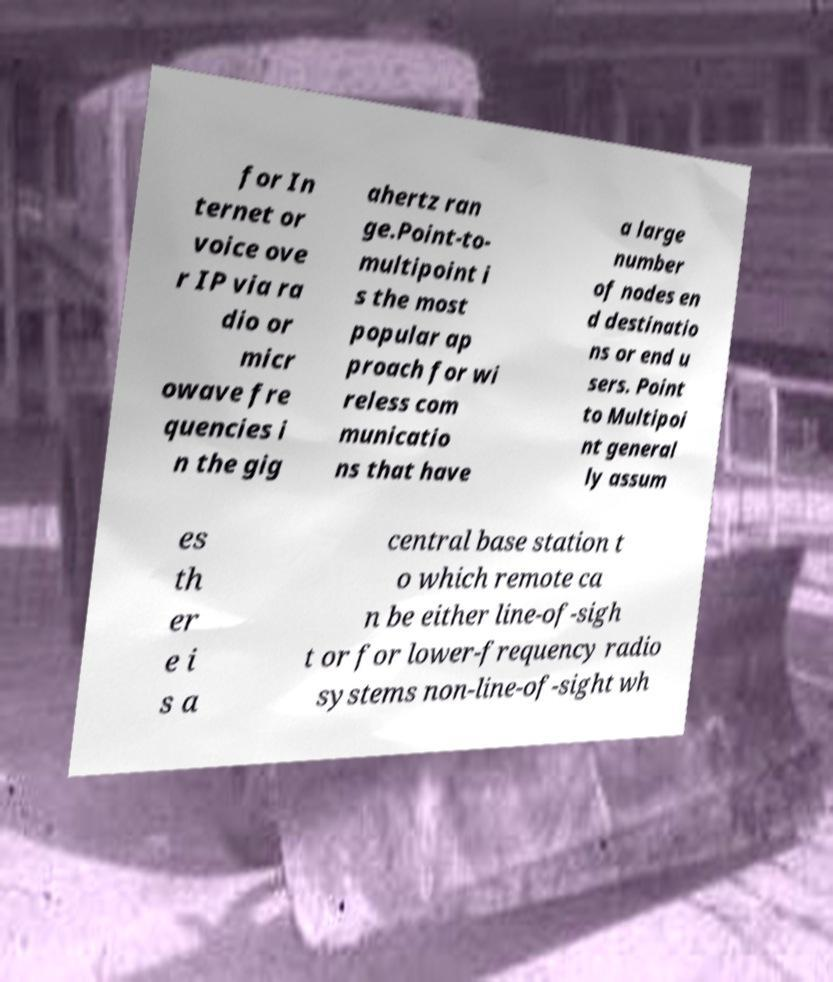I need the written content from this picture converted into text. Can you do that? for In ternet or voice ove r IP via ra dio or micr owave fre quencies i n the gig ahertz ran ge.Point-to- multipoint i s the most popular ap proach for wi reless com municatio ns that have a large number of nodes en d destinatio ns or end u sers. Point to Multipoi nt general ly assum es th er e i s a central base station t o which remote ca n be either line-of-sigh t or for lower-frequency radio systems non-line-of-sight wh 